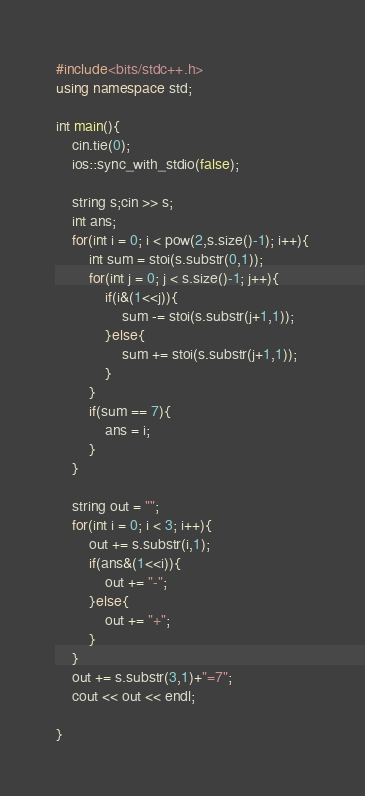Convert code to text. <code><loc_0><loc_0><loc_500><loc_500><_C++_>#include<bits/stdc++.h>
using namespace std;

int main(){
	cin.tie(0);
	ios::sync_with_stdio(false);

	string s;cin >> s;
	int ans;
	for(int i = 0; i < pow(2,s.size()-1); i++){
		int sum = stoi(s.substr(0,1));
		for(int j = 0; j < s.size()-1; j++){
			if(i&(1<<j)){
				sum -= stoi(s.substr(j+1,1));
			}else{
				sum += stoi(s.substr(j+1,1));
			}
		}
		if(sum == 7){
			ans = i;
		}
	}

	string out = "";
	for(int i = 0; i < 3; i++){
		out += s.substr(i,1);
		if(ans&(1<<i)){
			out += "-";
		}else{
			out += "+";
		}
	}
	out += s.substr(3,1)+"=7";
	cout << out << endl;
	
}
</code> 